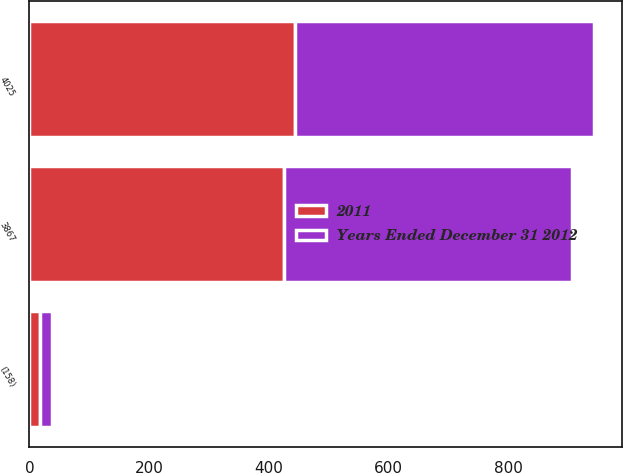Convert chart to OTSL. <chart><loc_0><loc_0><loc_500><loc_500><stacked_bar_chart><ecel><fcel>4025<fcel>(158)<fcel>3867<nl><fcel>2011<fcel>442.8<fcel>17.1<fcel>425.7<nl><fcel>Years Ended December 31 2012<fcel>499.9<fcel>19.8<fcel>480.2<nl></chart> 